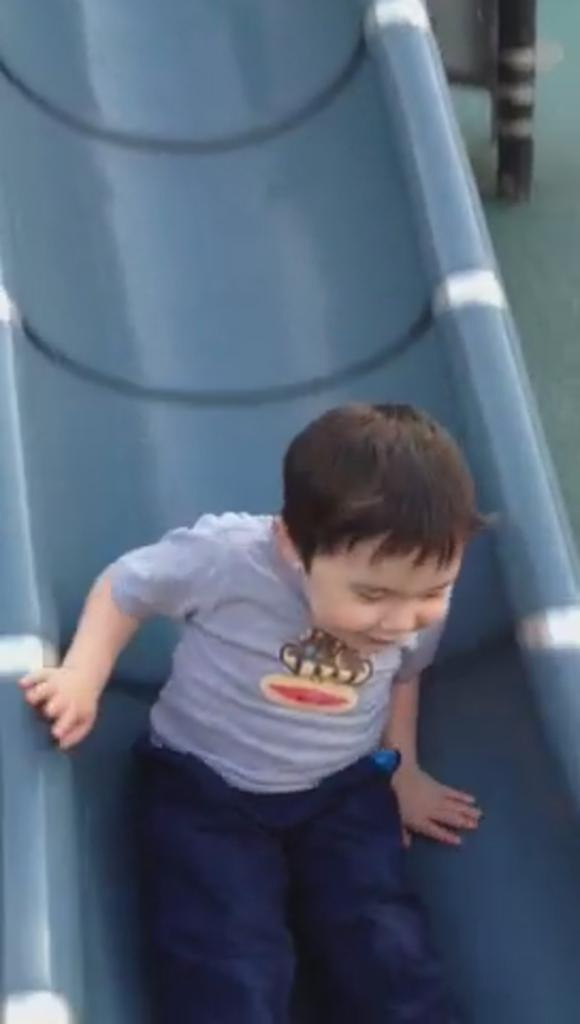What is the main subject of the image? The main subject of the image is a boy. What is the boy doing in the image? The boy is sliding down from a slider. How far does the boy swim in the image? There is no swimming activity depicted in the image; the boy is sliding down from a slider. What is the rate at which the boy slides down the slider in the image? The image does not provide information about the speed or rate at which the boy is sliding down the slider. 